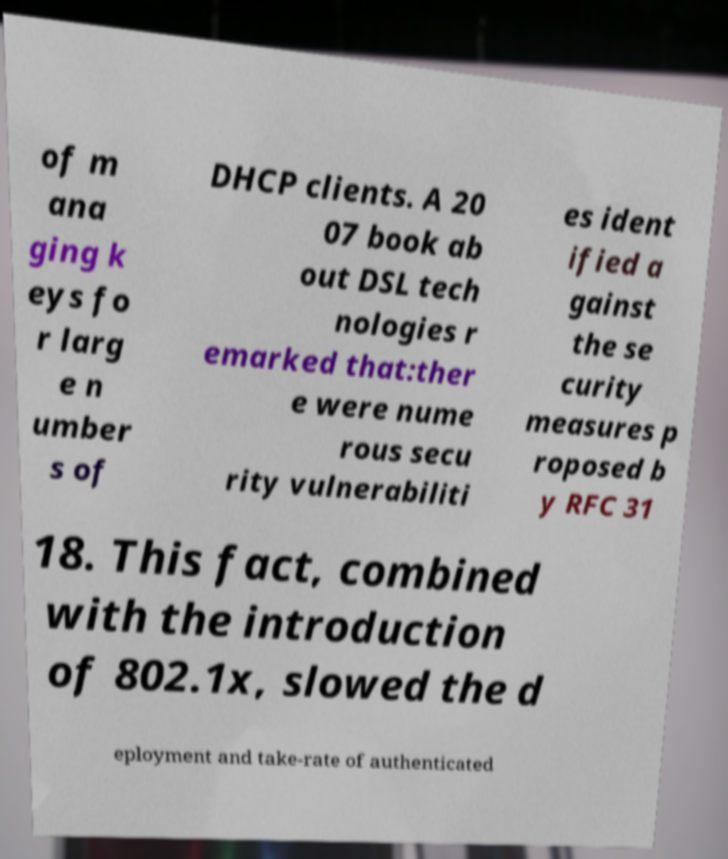I need the written content from this picture converted into text. Can you do that? of m ana ging k eys fo r larg e n umber s of DHCP clients. A 20 07 book ab out DSL tech nologies r emarked that:ther e were nume rous secu rity vulnerabiliti es ident ified a gainst the se curity measures p roposed b y RFC 31 18. This fact, combined with the introduction of 802.1x, slowed the d eployment and take-rate of authenticated 